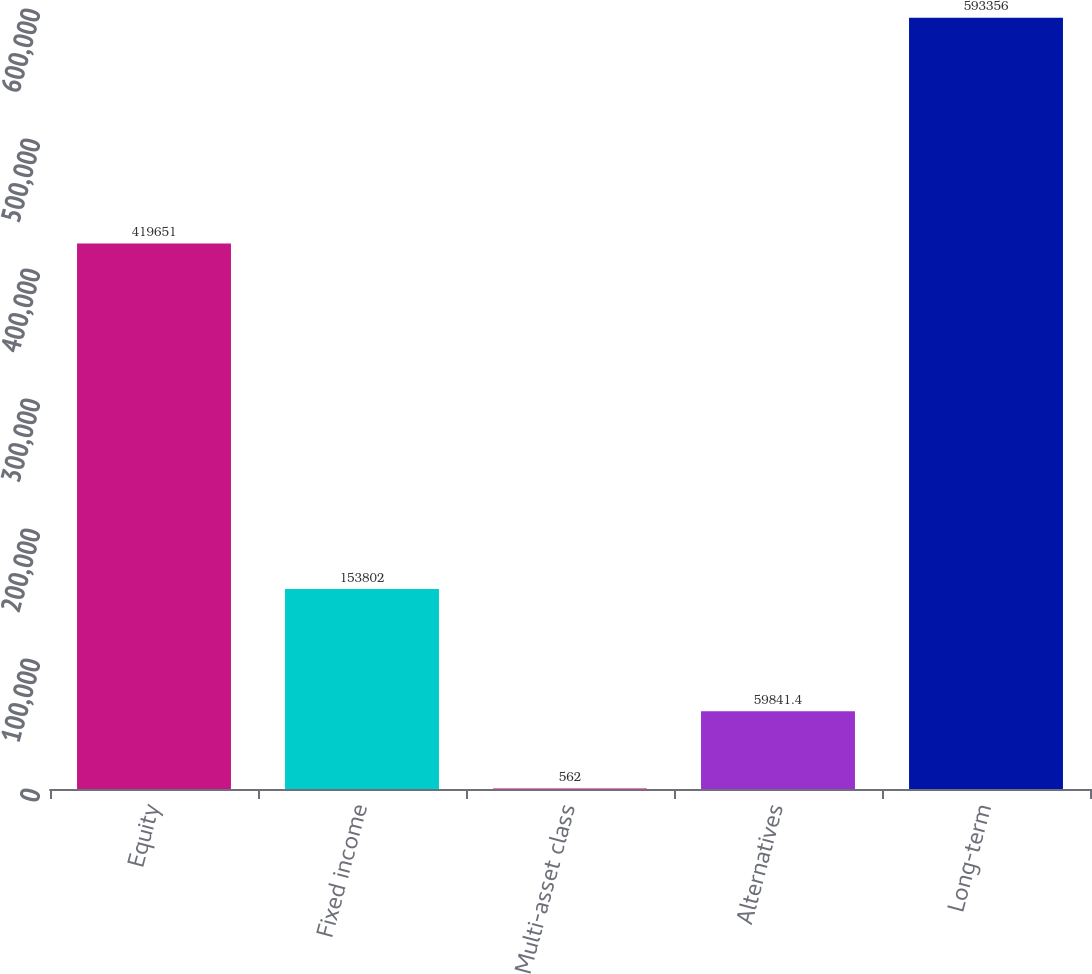Convert chart. <chart><loc_0><loc_0><loc_500><loc_500><bar_chart><fcel>Equity<fcel>Fixed income<fcel>Multi-asset class<fcel>Alternatives<fcel>Long-term<nl><fcel>419651<fcel>153802<fcel>562<fcel>59841.4<fcel>593356<nl></chart> 